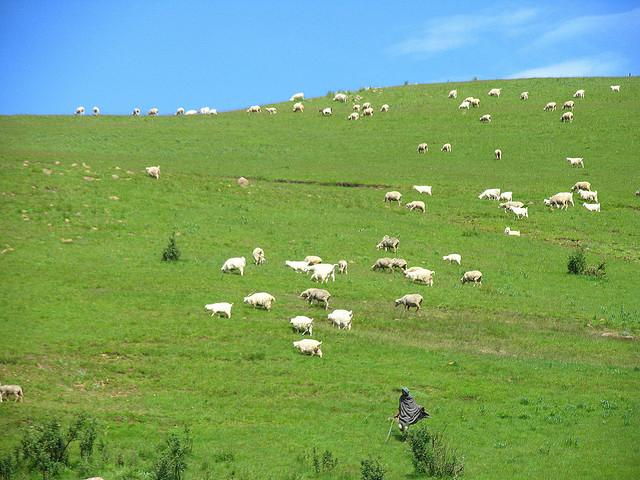What might the man be attempting to do with the animals? herd 